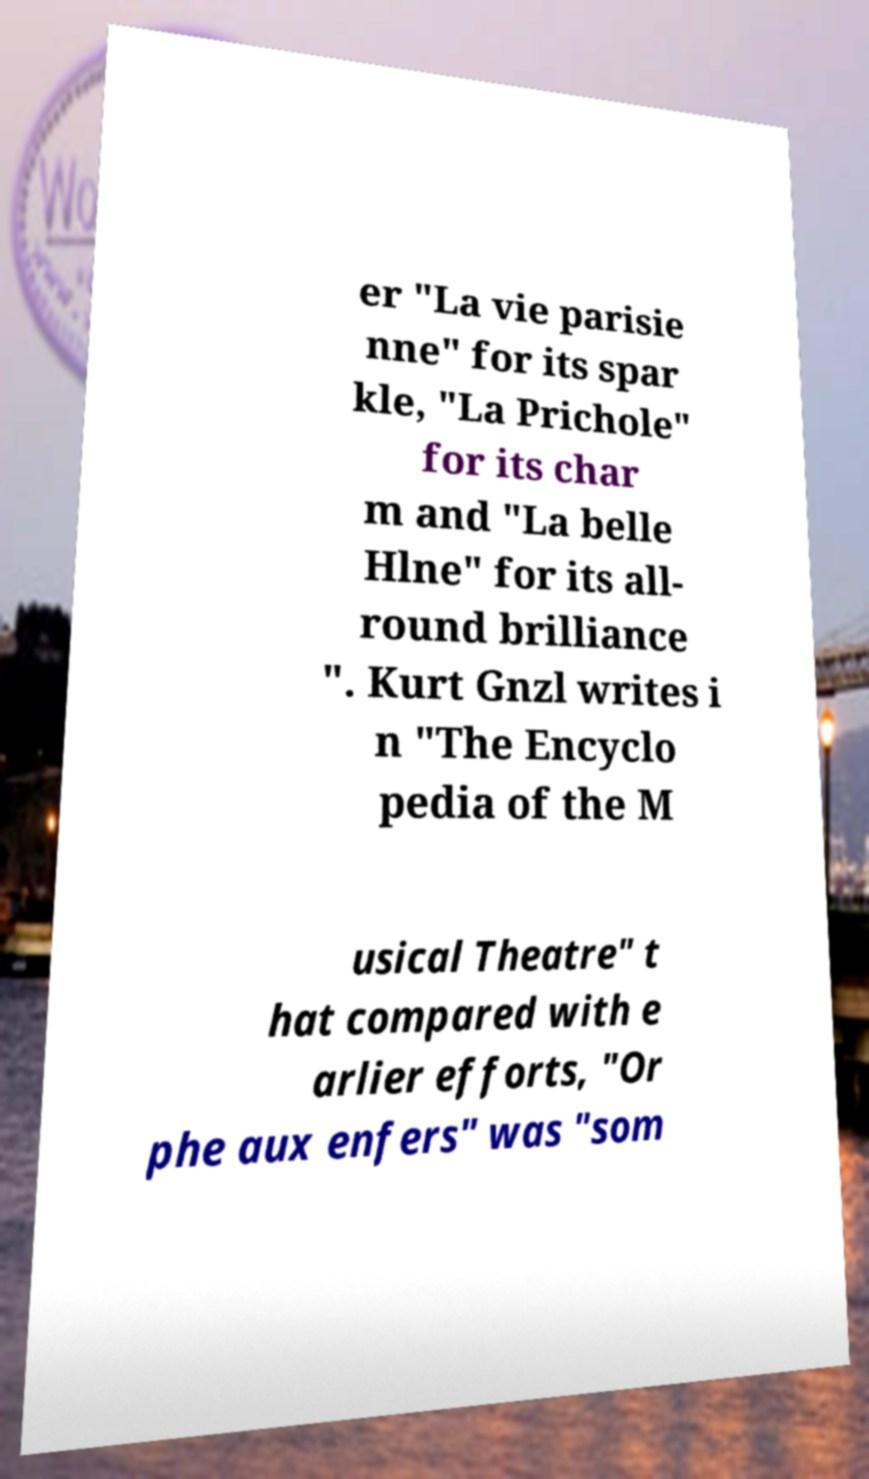What messages or text are displayed in this image? I need them in a readable, typed format. er "La vie parisie nne" for its spar kle, "La Prichole" for its char m and "La belle Hlne" for its all- round brilliance ". Kurt Gnzl writes i n "The Encyclo pedia of the M usical Theatre" t hat compared with e arlier efforts, "Or phe aux enfers" was "som 